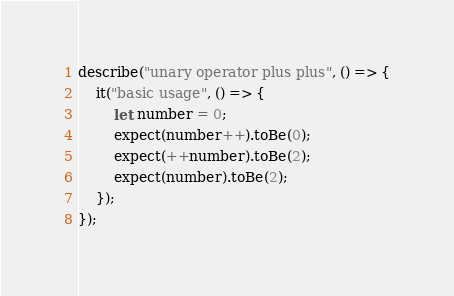<code> <loc_0><loc_0><loc_500><loc_500><_JavaScript_>describe("unary operator plus plus", () => {
    it("basic usage", () => {
        let number = 0;
        expect(number++).toBe(0);
        expect(++number).toBe(2);
        expect(number).toBe(2);
    });
});
</code> 